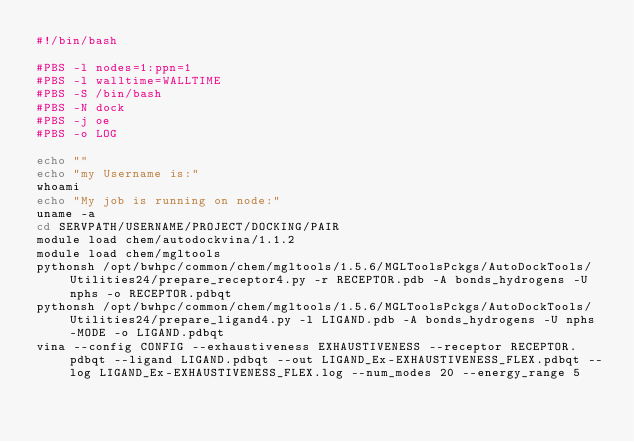Convert code to text. <code><loc_0><loc_0><loc_500><loc_500><_Bash_>#!/bin/bash

#PBS -l nodes=1:ppn=1
#PBS -l walltime=WALLTIME
#PBS -S /bin/bash
#PBS -N dock
#PBS -j oe
#PBS -o LOG

echo ""
echo "my Username is:"
whoami
echo "My job is running on node:"
uname -a
cd SERVPATH/USERNAME/PROJECT/DOCKING/PAIR
module load chem/autodockvina/1.1.2
module load chem/mgltools
pythonsh /opt/bwhpc/common/chem/mgltools/1.5.6/MGLToolsPckgs/AutoDockTools/Utilities24/prepare_receptor4.py -r RECEPTOR.pdb -A bonds_hydrogens -U nphs -o RECEPTOR.pdbqt
pythonsh /opt/bwhpc/common/chem/mgltools/1.5.6/MGLToolsPckgs/AutoDockTools/Utilities24/prepare_ligand4.py -l LIGAND.pdb -A bonds_hydrogens -U nphs -MODE -o LIGAND.pdbqt
vina --config CONFIG --exhaustiveness EXHAUSTIVENESS --receptor RECEPTOR.pdbqt --ligand LIGAND.pdbqt --out LIGAND_Ex-EXHAUSTIVENESS_FLEX.pdbqt --log LIGAND_Ex-EXHAUSTIVENESS_FLEX.log --num_modes 20 --energy_range 5
</code> 